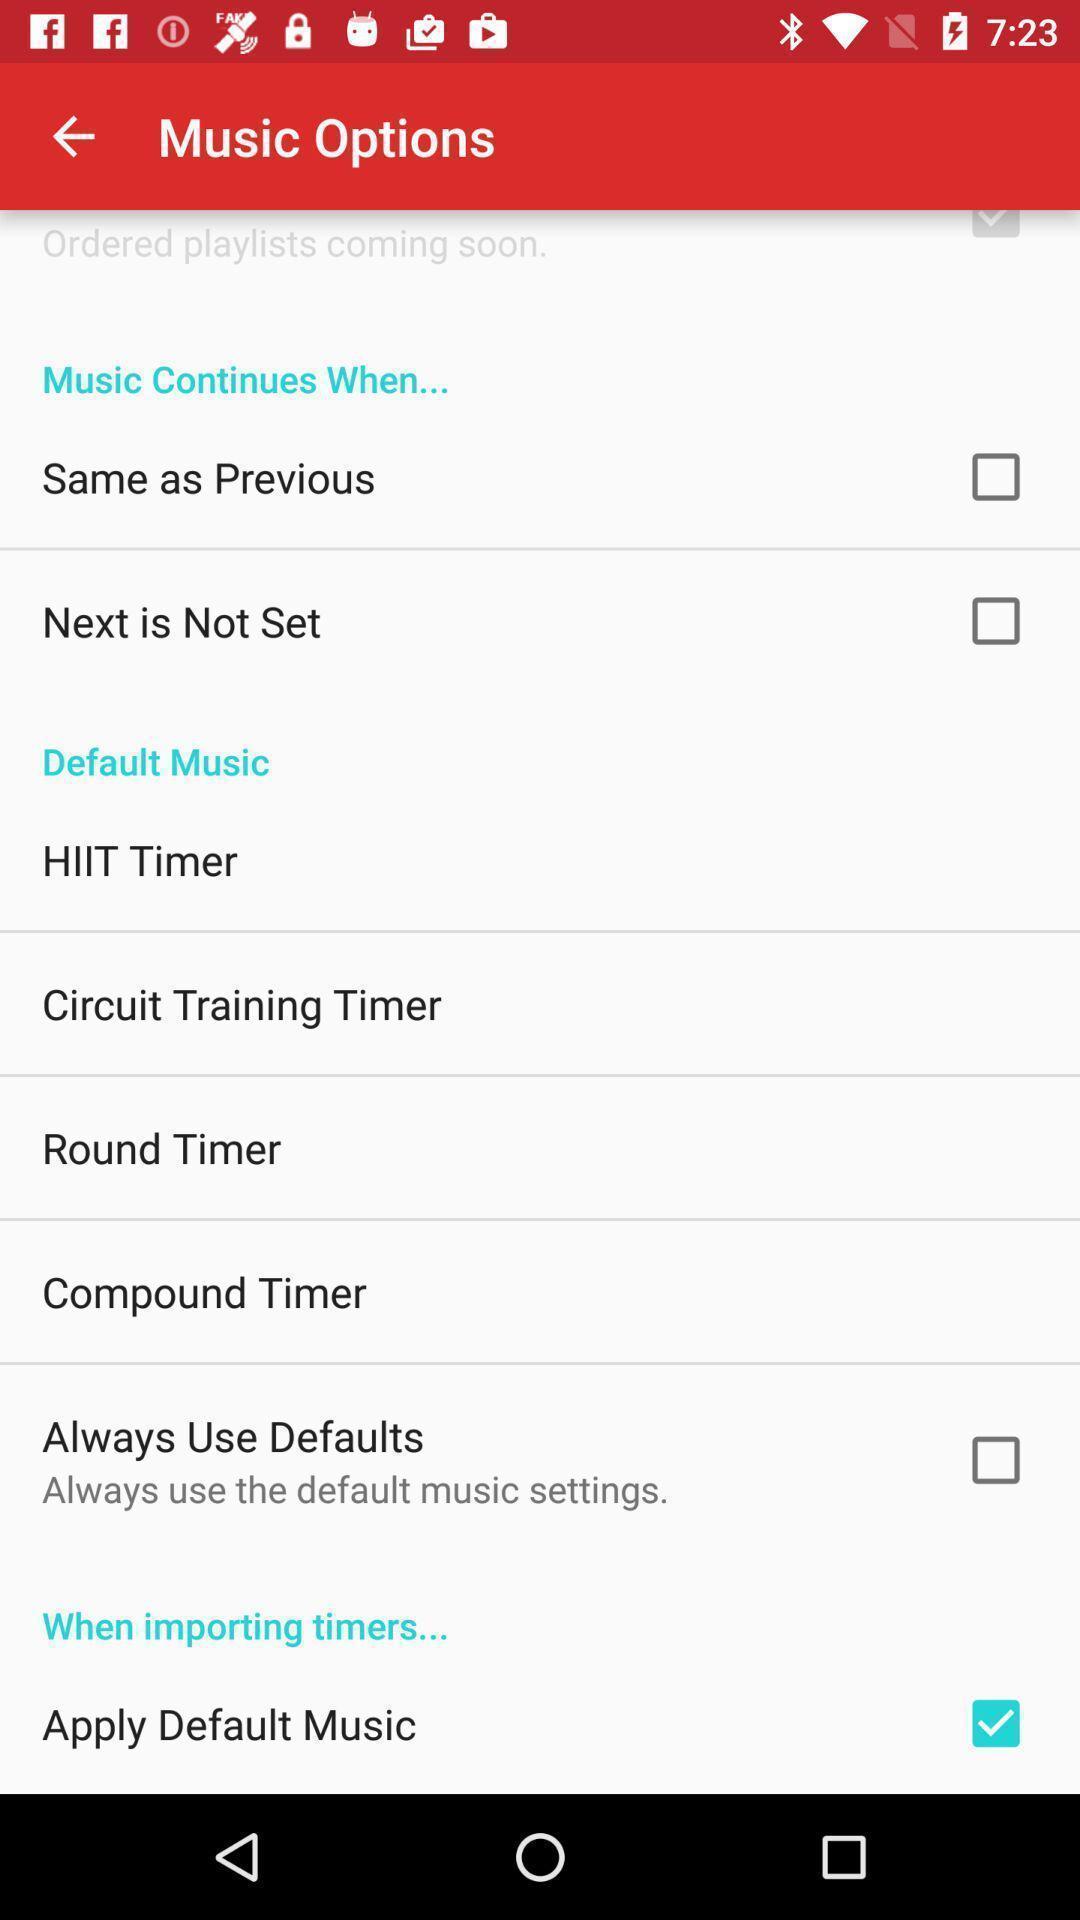Tell me what you see in this picture. Settings related options in a workout timer app. 